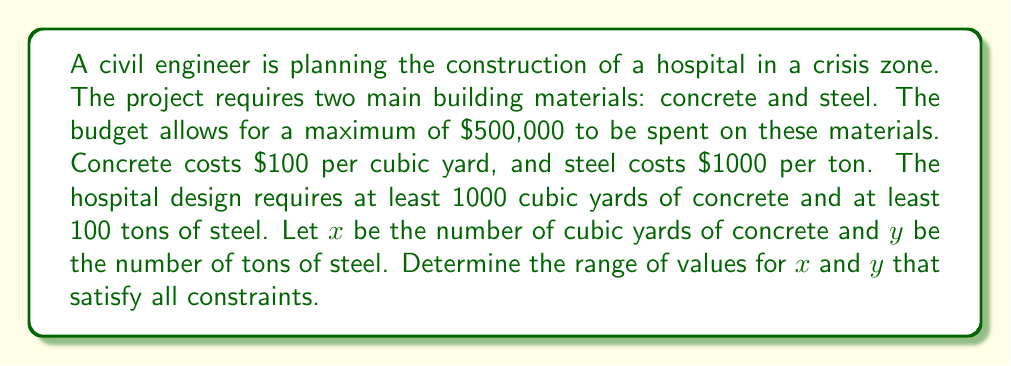Give your solution to this math problem. 1. Let's define our variables:
   $x$ = cubic yards of concrete
   $y$ = tons of steel

2. We can form inequalities based on the given information:

   Budget constraint: $100x + 1000y \leq 500000$
   Minimum concrete requirement: $x \geq 1000$
   Minimum steel requirement: $y \geq 100$
   Non-negativity constraints: $x \geq 0$, $y \geq 0$

3. Simplify the budget constraint:
   $100x + 1000y \leq 500000$
   $x + 10y \leq 5000$

4. Our system of inequalities is now:
   $$\begin{cases}
   x + 10y \leq 5000 \\
   x \geq 1000 \\
   y \geq 100 \\
   x \geq 0 \\
   y \geq 0
   \end{cases}$$

5. The non-negativity constraints are satisfied by the minimum requirements, so we can omit them.

6. To find the maximum possible value for $x$, we set $y$ to its minimum (100):
   $x + 10(100) \leq 5000$
   $x \leq 4000$

7. To find the maximum possible value for $y$, we set $x$ to its minimum (1000):
   $1000 + 10y \leq 5000$
   $10y \leq 4000$
   $y \leq 400$

Therefore, the range of values for $x$ and $y$ that satisfy all constraints are:
$1000 \leq x \leq 4000$
$100 \leq y \leq 400$
Answer: $1000 \leq x \leq 4000$, $100 \leq y \leq 400$ 